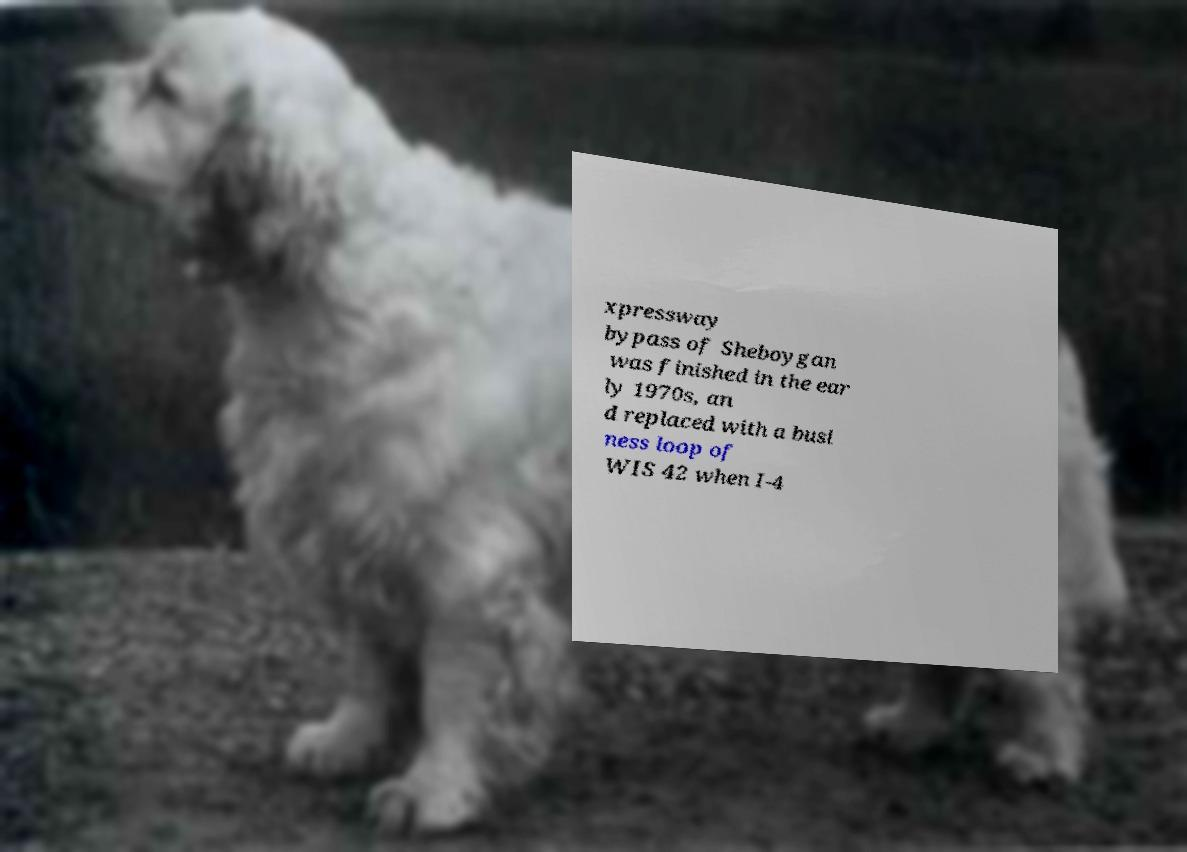For documentation purposes, I need the text within this image transcribed. Could you provide that? xpressway bypass of Sheboygan was finished in the ear ly 1970s, an d replaced with a busi ness loop of WIS 42 when I-4 